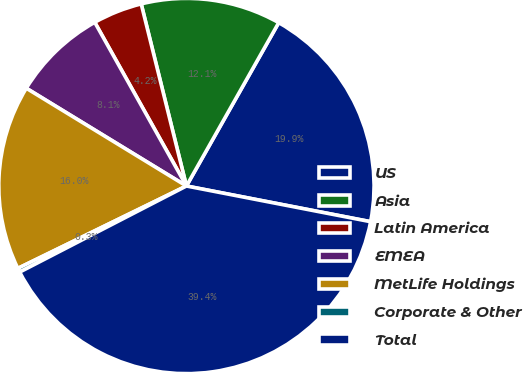Convert chart. <chart><loc_0><loc_0><loc_500><loc_500><pie_chart><fcel>US<fcel>Asia<fcel>Latin America<fcel>EMEA<fcel>MetLife Holdings<fcel>Corporate & Other<fcel>Total<nl><fcel>19.86%<fcel>12.06%<fcel>4.25%<fcel>8.15%<fcel>15.96%<fcel>0.35%<fcel>39.37%<nl></chart> 